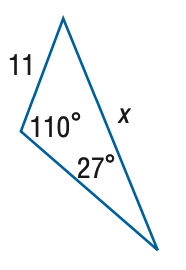Answer the mathemtical geometry problem and directly provide the correct option letter.
Question: Find x. Round side measure to the nearest tenth.
Choices: A: 5.3 B: 7.3 C: 16.5 D: 22.8 D 